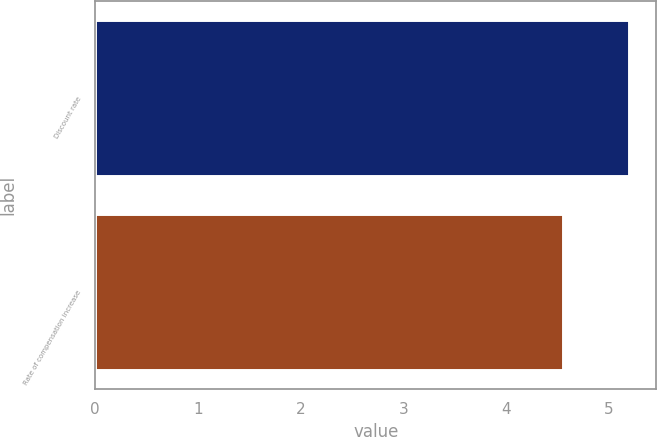<chart> <loc_0><loc_0><loc_500><loc_500><bar_chart><fcel>Discount rate<fcel>Rate of compensation increase<nl><fcel>5.2<fcel>4.55<nl></chart> 